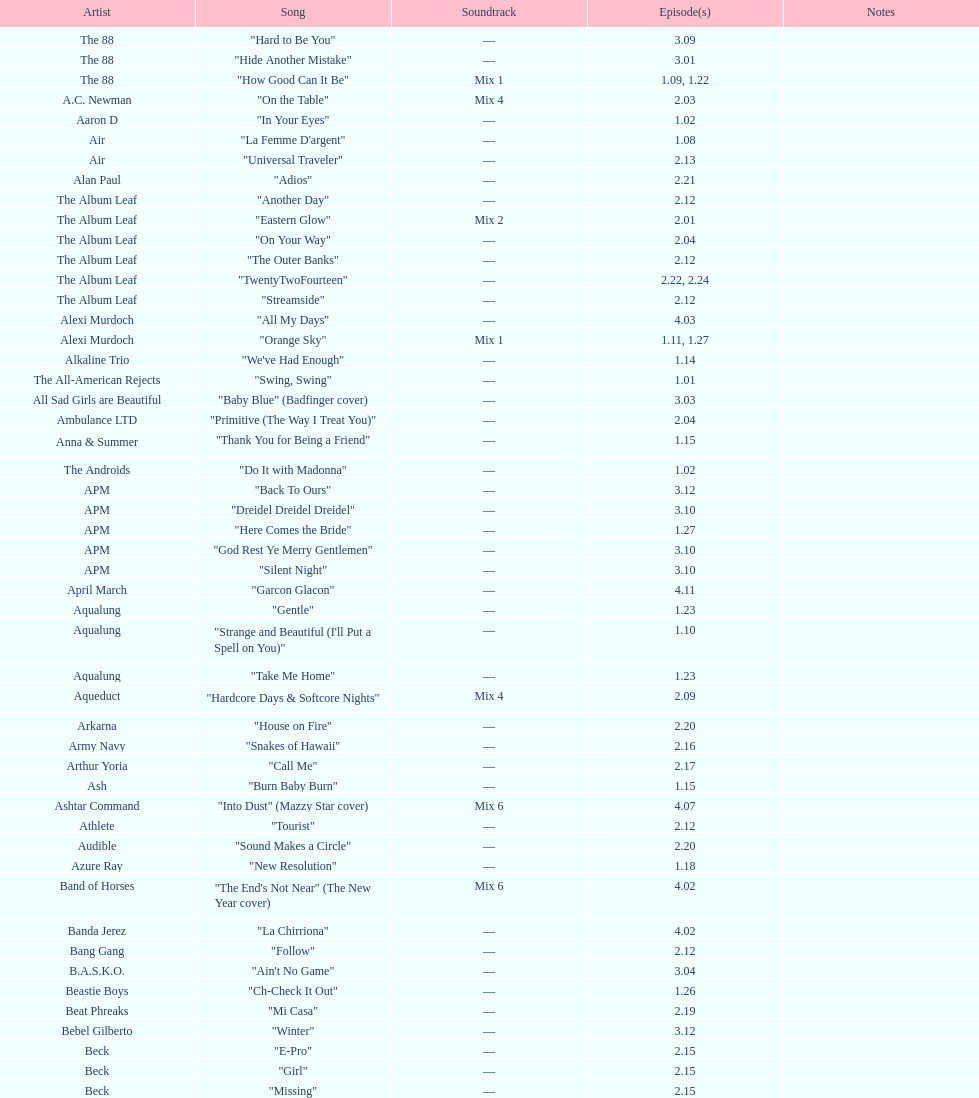00? 27. 